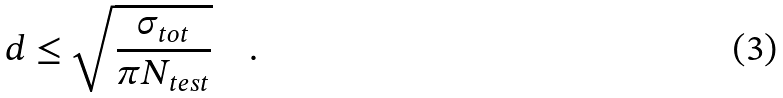Convert formula to latex. <formula><loc_0><loc_0><loc_500><loc_500>d \leq \sqrt { \frac { \sigma _ { t o t } } { \pi N _ { t e s t } } } \quad .</formula> 